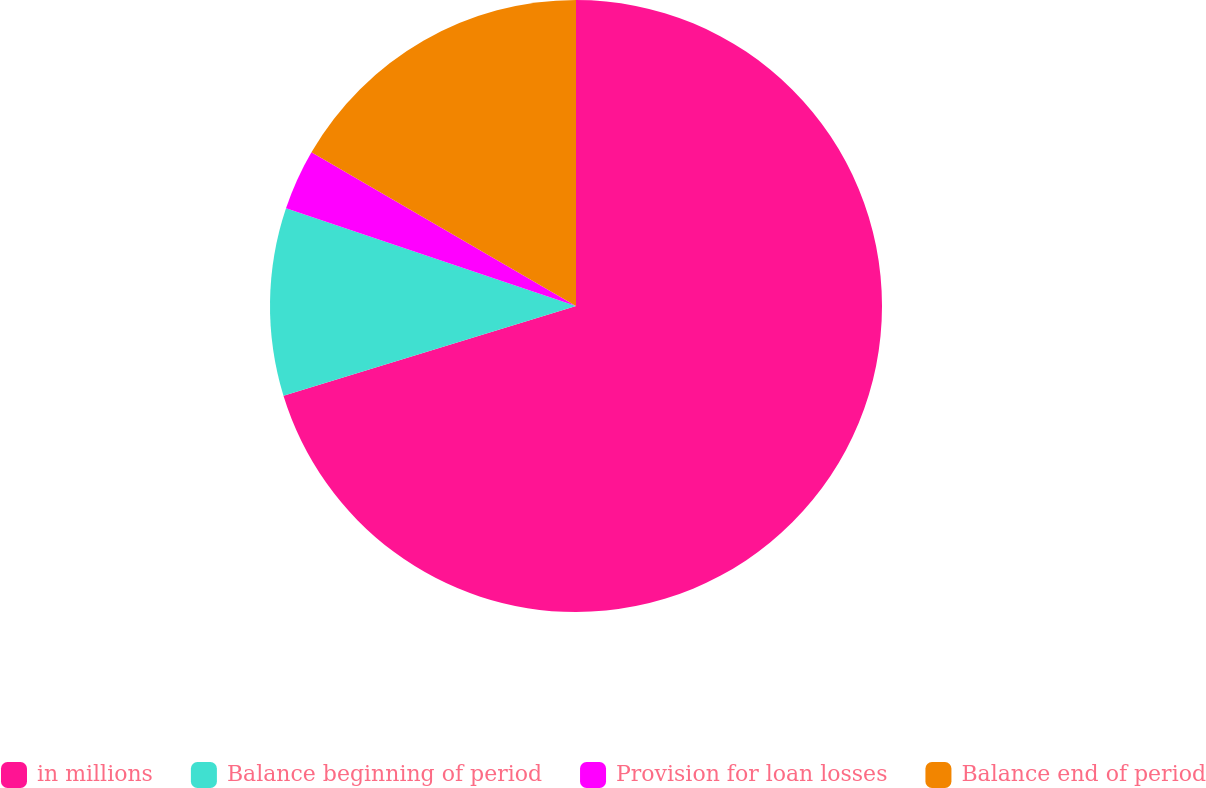Convert chart. <chart><loc_0><loc_0><loc_500><loc_500><pie_chart><fcel>in millions<fcel>Balance beginning of period<fcel>Provision for loan losses<fcel>Balance end of period<nl><fcel>70.26%<fcel>9.91%<fcel>3.21%<fcel>16.62%<nl></chart> 